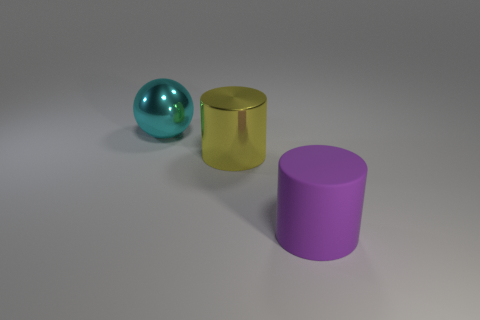Add 3 purple matte objects. How many objects exist? 6 Subtract all cylinders. How many objects are left? 1 Add 3 big metallic things. How many big metallic things are left? 5 Add 1 big yellow cylinders. How many big yellow cylinders exist? 2 Subtract 1 yellow cylinders. How many objects are left? 2 Subtract all purple rubber cylinders. Subtract all cyan objects. How many objects are left? 1 